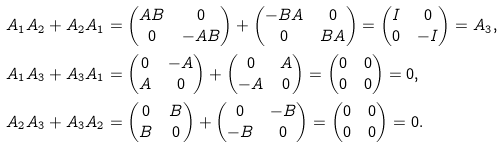<formula> <loc_0><loc_0><loc_500><loc_500>A _ { 1 } A _ { 2 } + A _ { 2 } A _ { 1 } & = \begin{pmatrix} A B & 0 \\ 0 & - A B \end{pmatrix} + \begin{pmatrix} - B A & 0 \\ 0 & B A \end{pmatrix} = \begin{pmatrix} I & 0 \\ 0 & - I \end{pmatrix} = A _ { 3 } , \\ A _ { 1 } A _ { 3 } + A _ { 3 } A _ { 1 } & = \begin{pmatrix} 0 & - A \\ A & 0 \end{pmatrix} + \begin{pmatrix} 0 & A \\ - A & 0 \end{pmatrix} = \begin{pmatrix} 0 & 0 \\ 0 & 0 \end{pmatrix} = 0 , \\ A _ { 2 } A _ { 3 } + A _ { 3 } A _ { 2 } & = \begin{pmatrix} 0 & B \\ B & 0 \end{pmatrix} + \begin{pmatrix} 0 & - B \\ - B & 0 \end{pmatrix} = \begin{pmatrix} 0 & 0 \\ 0 & 0 \end{pmatrix} = 0 .</formula> 